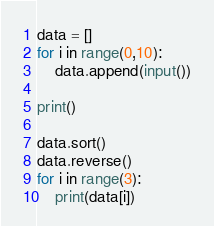<code> <loc_0><loc_0><loc_500><loc_500><_Python_>data = []
for i in range(0,10):
    data.append(input())

print()

data.sort()
data.reverse()
for i in range(3):
    print(data[i])

</code> 